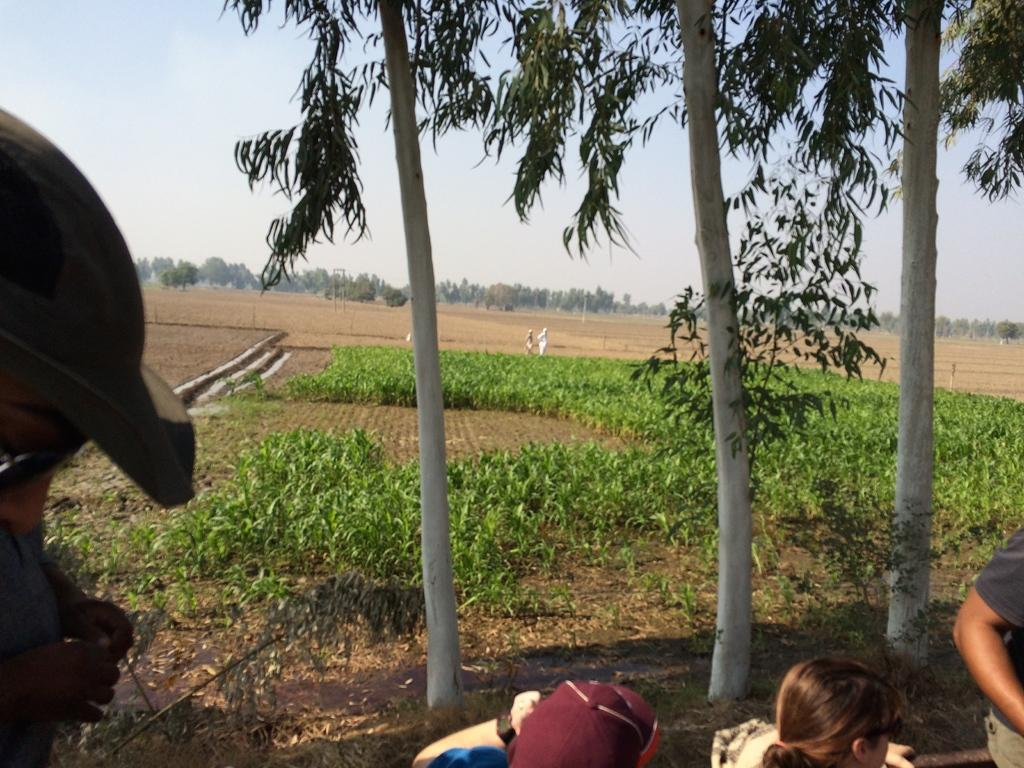What type of terrain is depicted in the image? There is a land with mud in the image. What kind of vegetation can be seen in the image? There are plants and trees in the image. What color is the sky in the image? The sky is blue in the image. Can you see a bubble floating in the sky in the image? No, there is no bubble visible in the image. 